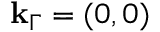Convert formula to latex. <formula><loc_0><loc_0><loc_500><loc_500>k _ { \Gamma } = ( 0 , 0 )</formula> 